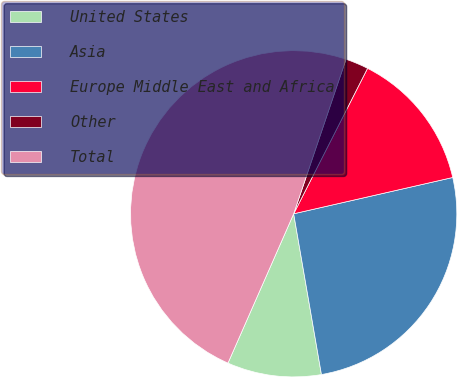Convert chart. <chart><loc_0><loc_0><loc_500><loc_500><pie_chart><fcel>United States<fcel>Asia<fcel>Europe Middle East and Africa<fcel>Other<fcel>Total<nl><fcel>9.32%<fcel>25.85%<fcel>13.95%<fcel>2.28%<fcel>48.6%<nl></chart> 